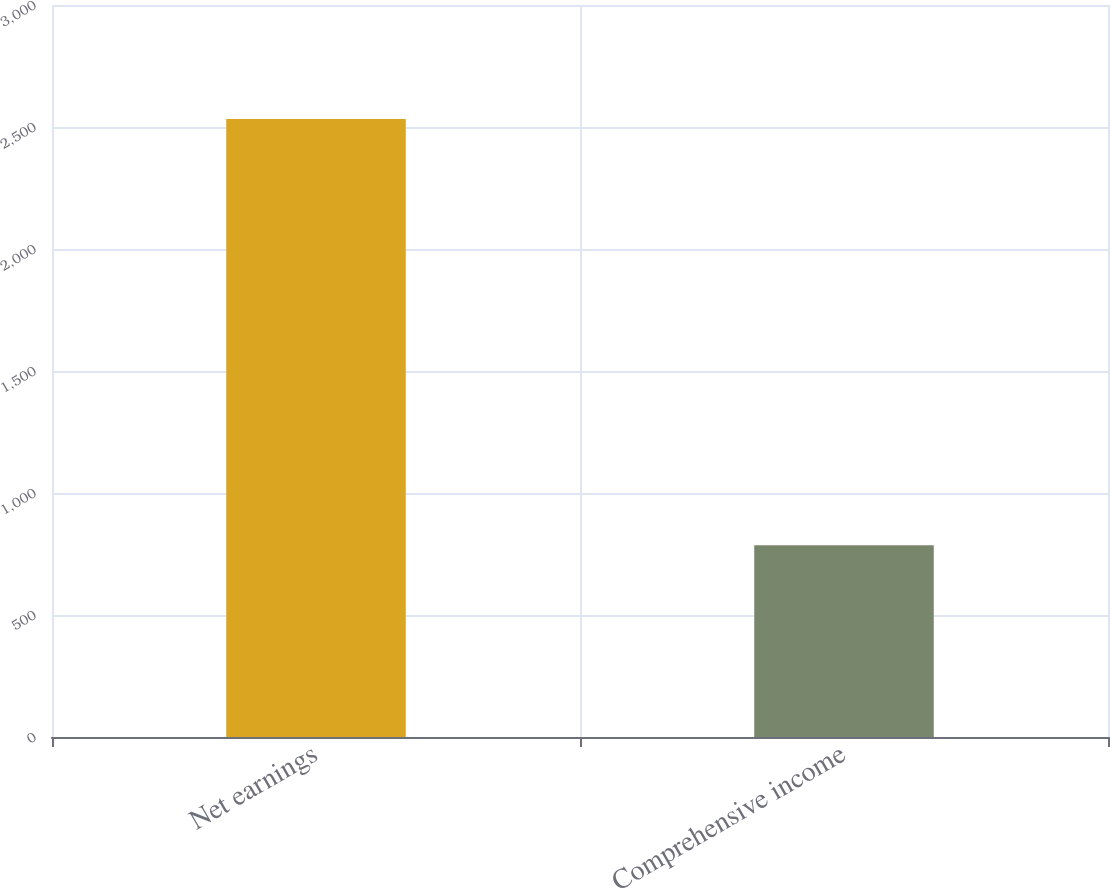Convert chart to OTSL. <chart><loc_0><loc_0><loc_500><loc_500><bar_chart><fcel>Net earnings<fcel>Comprehensive income<nl><fcel>2533<fcel>786<nl></chart> 